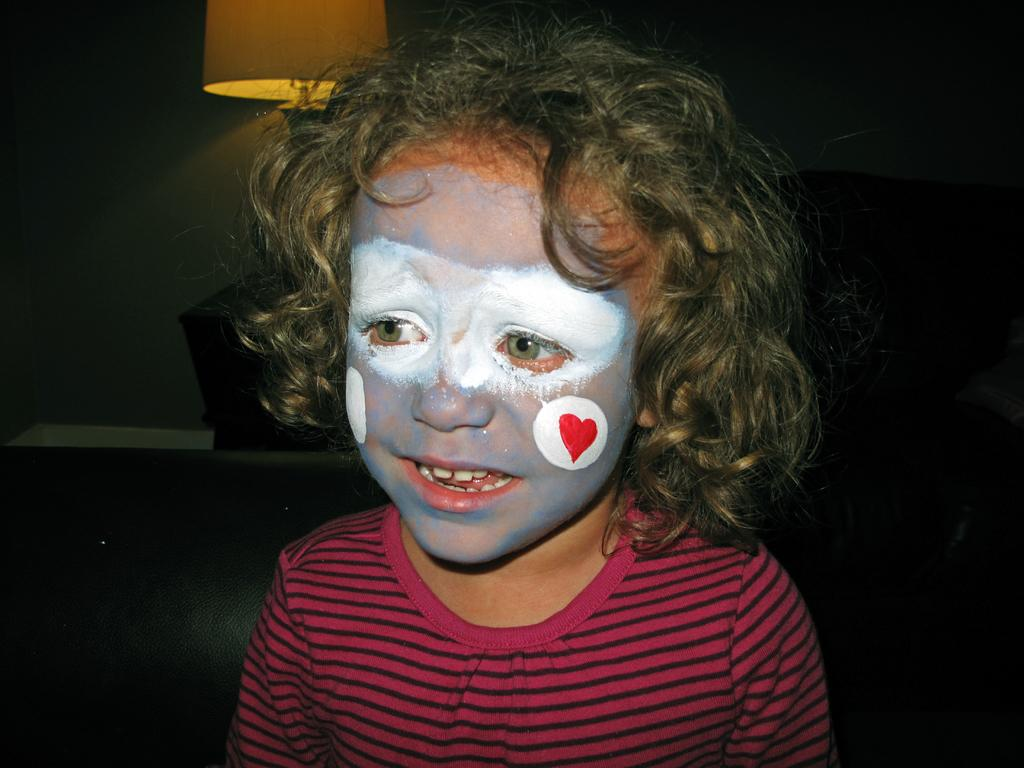What is the main subject of the image? The main subject of the image is a baby. What is the baby doing in the image? The baby is standing in the image. How has the baby decorated herself in the image? The baby has painted her face with colors. What object can be seen at the top left of the image? There is a lamp at the top left of the image. What type of treatment is the baby receiving in the image? There is no indication in the image that the baby is receiving any treatment. Is the baby a spy in the image? There is no indication in the image that the baby is a spy. What type of music is playing in the background of the image? There is no indication in the image that any music is playing. 